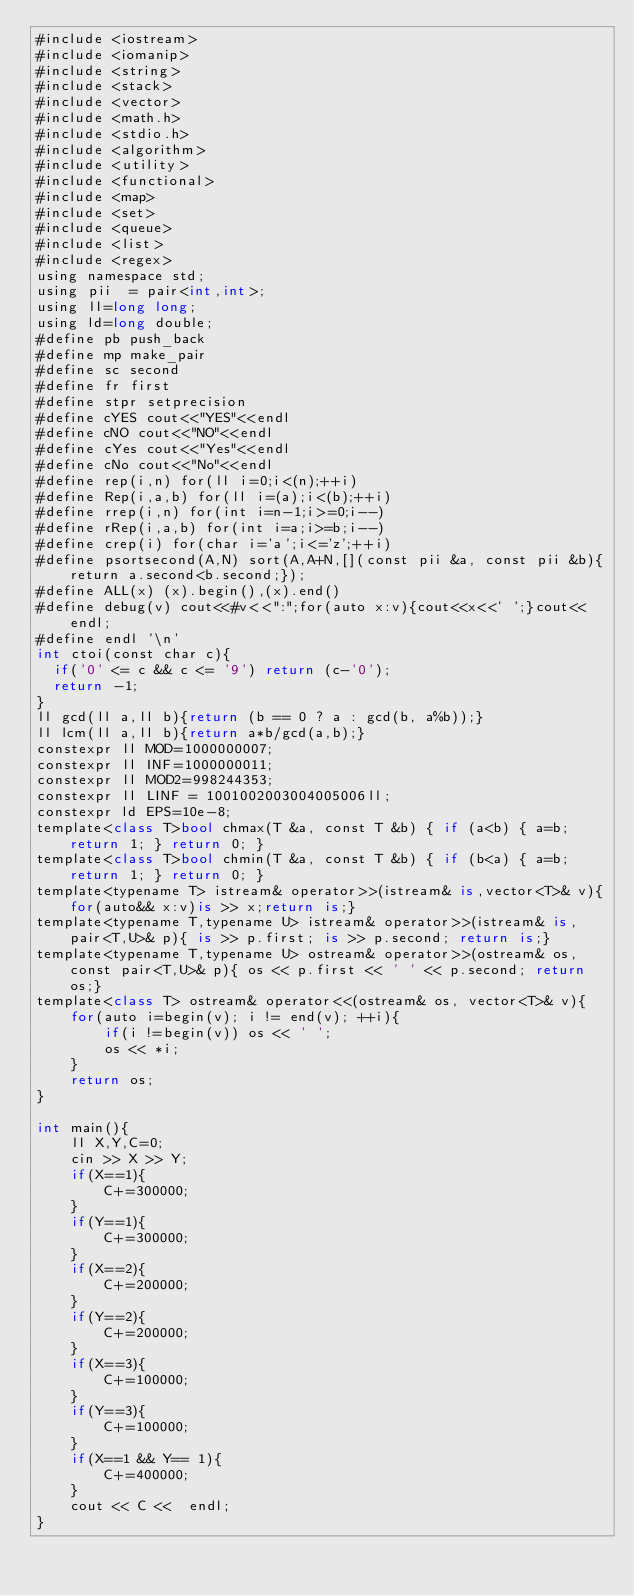<code> <loc_0><loc_0><loc_500><loc_500><_Python_>#include <iostream>
#include <iomanip>
#include <string>
#include <stack>
#include <vector>
#include <math.h>
#include <stdio.h>
#include <algorithm>
#include <utility>
#include <functional>
#include <map>
#include <set>
#include <queue>
#include <list>
#include <regex>
using namespace std;
using pii  = pair<int,int>;
using ll=long long;
using ld=long double;
#define pb push_back
#define mp make_pair
#define sc second
#define fr first
#define stpr setprecision
#define cYES cout<<"YES"<<endl
#define cNO cout<<"NO"<<endl
#define cYes cout<<"Yes"<<endl
#define cNo cout<<"No"<<endl
#define rep(i,n) for(ll i=0;i<(n);++i)
#define Rep(i,a,b) for(ll i=(a);i<(b);++i)
#define rrep(i,n) for(int i=n-1;i>=0;i--)
#define rRep(i,a,b) for(int i=a;i>=b;i--)
#define crep(i) for(char i='a';i<='z';++i)
#define psortsecond(A,N) sort(A,A+N,[](const pii &a, const pii &b){return a.second<b.second;});
#define ALL(x) (x).begin(),(x).end()
#define debug(v) cout<<#v<<":";for(auto x:v){cout<<x<<' ';}cout<<endl;
#define endl '\n'
int ctoi(const char c){
  if('0' <= c && c <= '9') return (c-'0');
  return -1;
}
ll gcd(ll a,ll b){return (b == 0 ? a : gcd(b, a%b));}
ll lcm(ll a,ll b){return a*b/gcd(a,b);}
constexpr ll MOD=1000000007;
constexpr ll INF=1000000011;
constexpr ll MOD2=998244353;
constexpr ll LINF = 1001002003004005006ll;
constexpr ld EPS=10e-8;
template<class T>bool chmax(T &a, const T &b) { if (a<b) { a=b; return 1; } return 0; }
template<class T>bool chmin(T &a, const T &b) { if (b<a) { a=b; return 1; } return 0; }
template<typename T> istream& operator>>(istream& is,vector<T>& v){for(auto&& x:v)is >> x;return is;}
template<typename T,typename U> istream& operator>>(istream& is, pair<T,U>& p){ is >> p.first; is >> p.second; return is;}
template<typename T,typename U> ostream& operator>>(ostream& os, const pair<T,U>& p){ os << p.first << ' ' << p.second; return os;}
template<class T> ostream& operator<<(ostream& os, vector<T>& v){
    for(auto i=begin(v); i != end(v); ++i){
        if(i !=begin(v)) os << ' ';
        os << *i;
    }
    return os;
}

int main(){
    ll X,Y,C=0;
    cin >> X >> Y;
    if(X==1){
        C+=300000;
    }
    if(Y==1){
        C+=300000;
    }
    if(X==2){
        C+=200000;
    }
    if(Y==2){
        C+=200000;
    }
    if(X==3){
        C+=100000;
    }
    if(Y==3){
        C+=100000;
    }
    if(X==1 && Y== 1){
        C+=400000;
    }
    cout << C <<  endl;
}</code> 